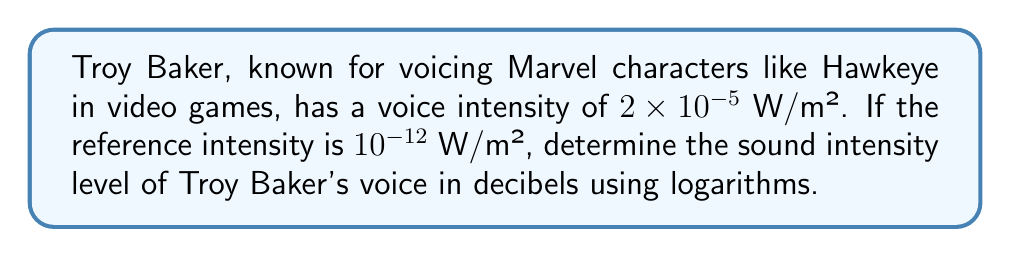Can you solve this math problem? To solve this problem, we'll use the formula for sound intensity level in decibels:

$$ \beta = 10 \log_{10} \left(\frac{I}{I_0}\right) $$

Where:
$\beta$ = sound intensity level in decibels (dB)
$I$ = intensity of the sound in W/m²
$I_0$ = reference intensity in W/m²

Given:
$I = 2 \times 10^{-5}$ W/m²
$I_0 = 10^{-12}$ W/m²

Step 1: Substitute the values into the formula.
$$ \beta = 10 \log_{10} \left(\frac{2 \times 10^{-5}}{10^{-12}}\right) $$

Step 2: Simplify the fraction inside the logarithm.
$$ \beta = 10 \log_{10} (2 \times 10^7) $$

Step 3: Use the logarithm property $\log_a(x \times y) = \log_a(x) + \log_a(y)$.
$$ \beta = 10 [\log_{10}(2) + \log_{10}(10^7)] $$

Step 4: Simplify $\log_{10}(10^7) = 7$.
$$ \beta = 10 [\log_{10}(2) + 7] $$

Step 5: Calculate $\log_{10}(2) \approx 0.301$.
$$ \beta = 10 [0.301 + 7] = 10 (7.301) = 73.01 $$

Therefore, the sound intensity level of Troy Baker's voice is approximately 73.01 dB.
Answer: 73.01 dB 